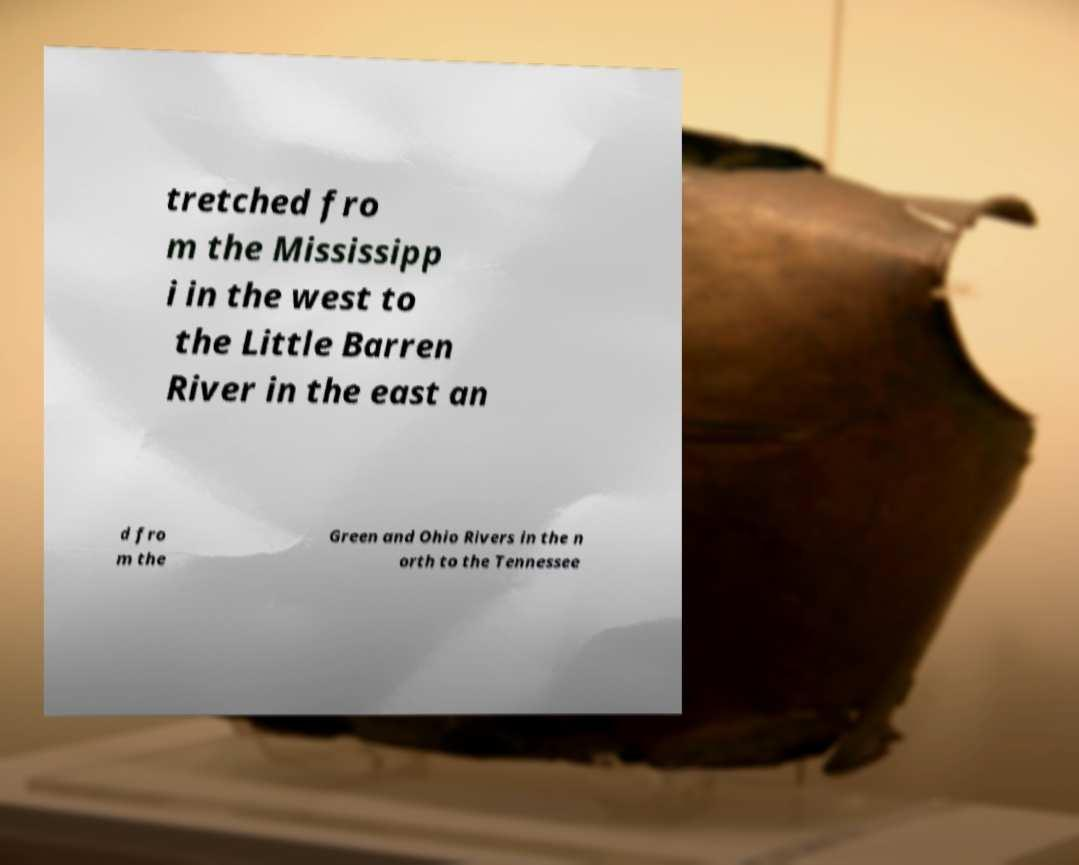For documentation purposes, I need the text within this image transcribed. Could you provide that? tretched fro m the Mississipp i in the west to the Little Barren River in the east an d fro m the Green and Ohio Rivers in the n orth to the Tennessee 